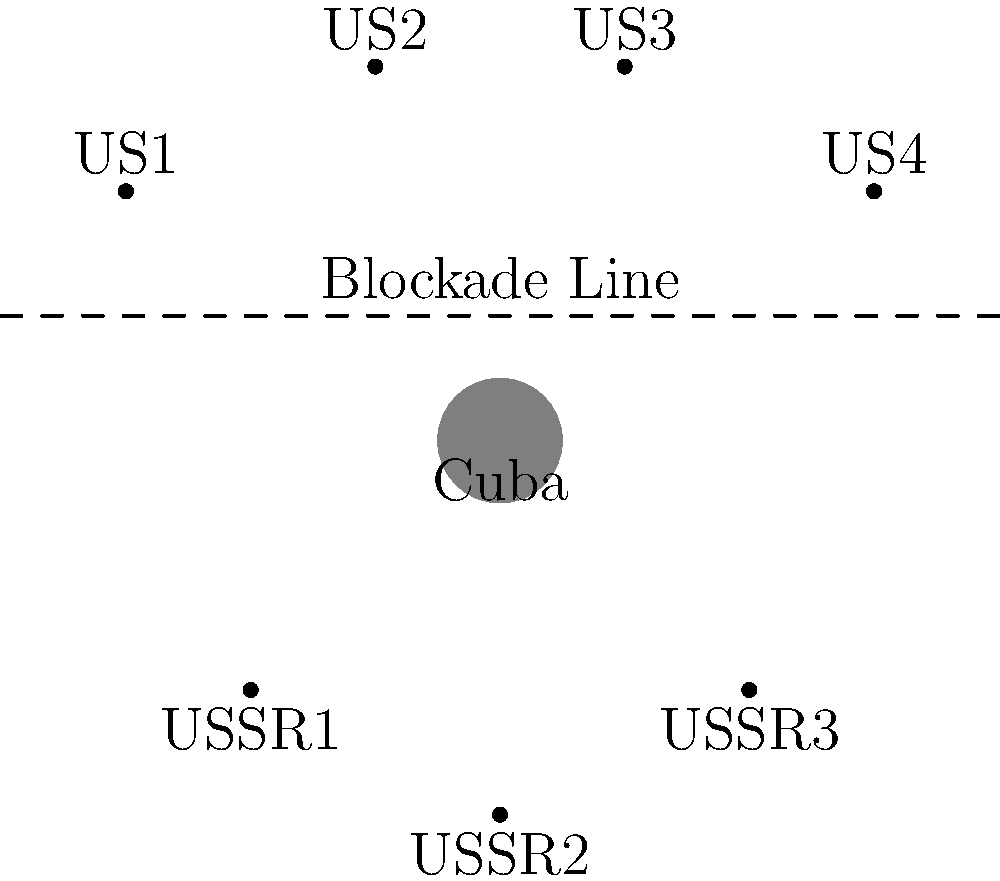Based on the diagram showing the positions of US and Soviet ships during the Cuban Missile Crisis, what strategic advantage did the US gain by establishing the naval blockade line north of Cuba? To answer this question, let's analyze the diagram step-by-step:

1. Cuba's position: Cuba is represented at the center of the diagram (0,0).

2. US ship positions: Four US ships (US1, US2, US3, US4) are positioned north of the blockade line.

3. Soviet ship positions: Three Soviet ships (USSR1, USSR2, USSR3) are positioned south of the blockade line, closer to Cuba.

4. Blockade line: A dashed line is drawn north of Cuba, separating the US ships from the Soviet ships and Cuba.

5. Strategic implications:
   a) The US ships form a barrier between Cuba and any approaching Soviet vessels.
   b) This positioning allows the US to intercept and inspect any ships heading towards Cuba.
   c) The blockade effectively cuts off Cuba from receiving further military supplies from the Soviet Union.
   d) The US maintains control over maritime traffic in the area without directly engaging Soviet ships.

6. Historical context: This naval blockade, officially called a "quarantine" to avoid the legal implications of a blockade, was a key element of the US strategy during the Cuban Missile Crisis. It aimed to prevent the Soviet Union from delivering additional missiles to Cuba while providing time for diplomatic negotiations.

Given this analysis, the strategic advantage gained by the US was the ability to control maritime access to Cuba, effectively preventing further Soviet military build-up on the island while minimizing the risk of direct military confrontation.
Answer: Control of maritime access to Cuba 